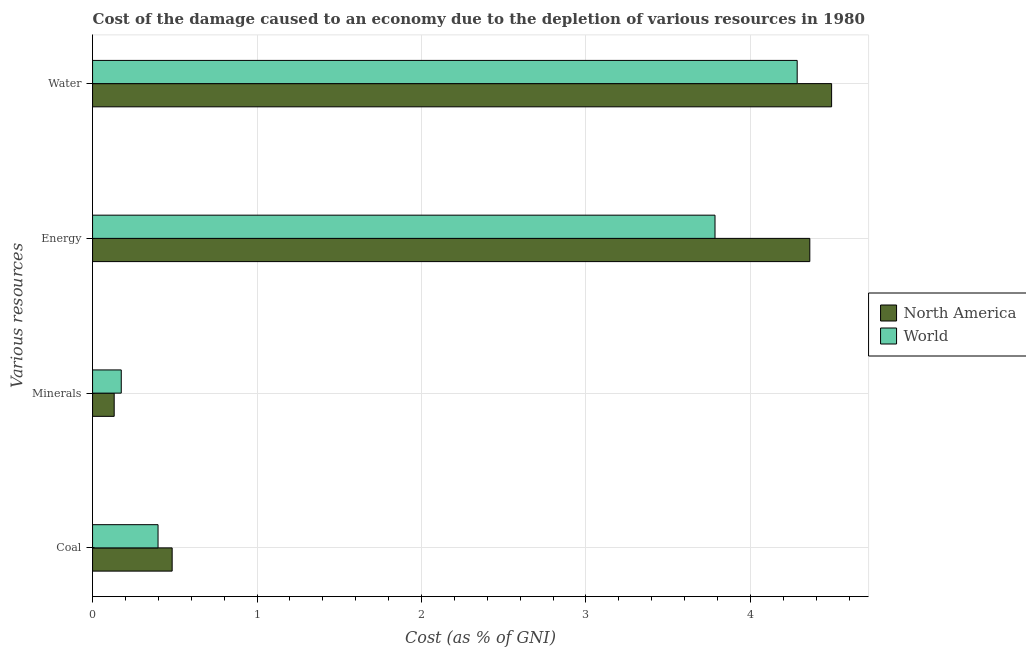How many different coloured bars are there?
Keep it short and to the point. 2. How many bars are there on the 4th tick from the top?
Keep it short and to the point. 2. How many bars are there on the 4th tick from the bottom?
Give a very brief answer. 2. What is the label of the 3rd group of bars from the top?
Provide a short and direct response. Minerals. What is the cost of damage due to depletion of minerals in North America?
Give a very brief answer. 0.13. Across all countries, what is the maximum cost of damage due to depletion of minerals?
Give a very brief answer. 0.17. Across all countries, what is the minimum cost of damage due to depletion of energy?
Provide a short and direct response. 3.78. In which country was the cost of damage due to depletion of energy maximum?
Give a very brief answer. North America. In which country was the cost of damage due to depletion of coal minimum?
Your answer should be very brief. World. What is the total cost of damage due to depletion of minerals in the graph?
Offer a terse response. 0.31. What is the difference between the cost of damage due to depletion of water in World and that in North America?
Ensure brevity in your answer.  -0.21. What is the difference between the cost of damage due to depletion of minerals in North America and the cost of damage due to depletion of energy in World?
Provide a short and direct response. -3.65. What is the average cost of damage due to depletion of coal per country?
Ensure brevity in your answer.  0.44. What is the difference between the cost of damage due to depletion of energy and cost of damage due to depletion of water in North America?
Your answer should be very brief. -0.13. What is the ratio of the cost of damage due to depletion of coal in North America to that in World?
Keep it short and to the point. 1.22. What is the difference between the highest and the second highest cost of damage due to depletion of minerals?
Give a very brief answer. 0.04. What is the difference between the highest and the lowest cost of damage due to depletion of coal?
Keep it short and to the point. 0.09. What does the 1st bar from the top in Minerals represents?
Give a very brief answer. World. What does the 1st bar from the bottom in Water represents?
Offer a very short reply. North America. Is it the case that in every country, the sum of the cost of damage due to depletion of coal and cost of damage due to depletion of minerals is greater than the cost of damage due to depletion of energy?
Your answer should be compact. No. Are all the bars in the graph horizontal?
Offer a terse response. Yes. How many countries are there in the graph?
Offer a terse response. 2. Does the graph contain any zero values?
Keep it short and to the point. No. What is the title of the graph?
Make the answer very short. Cost of the damage caused to an economy due to the depletion of various resources in 1980 . What is the label or title of the X-axis?
Your answer should be very brief. Cost (as % of GNI). What is the label or title of the Y-axis?
Your response must be concise. Various resources. What is the Cost (as % of GNI) in North America in Coal?
Your answer should be compact. 0.48. What is the Cost (as % of GNI) in World in Coal?
Ensure brevity in your answer.  0.4. What is the Cost (as % of GNI) in North America in Minerals?
Offer a very short reply. 0.13. What is the Cost (as % of GNI) of World in Minerals?
Your answer should be very brief. 0.17. What is the Cost (as % of GNI) of North America in Energy?
Provide a short and direct response. 4.36. What is the Cost (as % of GNI) of World in Energy?
Provide a short and direct response. 3.78. What is the Cost (as % of GNI) of North America in Water?
Provide a succinct answer. 4.49. What is the Cost (as % of GNI) of World in Water?
Provide a succinct answer. 4.28. Across all Various resources, what is the maximum Cost (as % of GNI) in North America?
Give a very brief answer. 4.49. Across all Various resources, what is the maximum Cost (as % of GNI) in World?
Your answer should be very brief. 4.28. Across all Various resources, what is the minimum Cost (as % of GNI) in North America?
Ensure brevity in your answer.  0.13. Across all Various resources, what is the minimum Cost (as % of GNI) of World?
Give a very brief answer. 0.17. What is the total Cost (as % of GNI) in North America in the graph?
Provide a succinct answer. 9.47. What is the total Cost (as % of GNI) of World in the graph?
Your answer should be compact. 8.64. What is the difference between the Cost (as % of GNI) of North America in Coal and that in Minerals?
Make the answer very short. 0.35. What is the difference between the Cost (as % of GNI) of World in Coal and that in Minerals?
Your response must be concise. 0.22. What is the difference between the Cost (as % of GNI) of North America in Coal and that in Energy?
Your answer should be very brief. -3.88. What is the difference between the Cost (as % of GNI) in World in Coal and that in Energy?
Give a very brief answer. -3.39. What is the difference between the Cost (as % of GNI) in North America in Coal and that in Water?
Provide a short and direct response. -4.01. What is the difference between the Cost (as % of GNI) of World in Coal and that in Water?
Offer a terse response. -3.89. What is the difference between the Cost (as % of GNI) in North America in Minerals and that in Energy?
Provide a succinct answer. -4.23. What is the difference between the Cost (as % of GNI) of World in Minerals and that in Energy?
Your response must be concise. -3.61. What is the difference between the Cost (as % of GNI) in North America in Minerals and that in Water?
Provide a short and direct response. -4.36. What is the difference between the Cost (as % of GNI) of World in Minerals and that in Water?
Keep it short and to the point. -4.11. What is the difference between the Cost (as % of GNI) of North America in Energy and that in Water?
Provide a succinct answer. -0.13. What is the difference between the Cost (as % of GNI) of World in Energy and that in Water?
Keep it short and to the point. -0.5. What is the difference between the Cost (as % of GNI) of North America in Coal and the Cost (as % of GNI) of World in Minerals?
Your answer should be compact. 0.31. What is the difference between the Cost (as % of GNI) of North America in Coal and the Cost (as % of GNI) of World in Energy?
Ensure brevity in your answer.  -3.3. What is the difference between the Cost (as % of GNI) in North America in Coal and the Cost (as % of GNI) in World in Water?
Your answer should be very brief. -3.8. What is the difference between the Cost (as % of GNI) of North America in Minerals and the Cost (as % of GNI) of World in Energy?
Your answer should be compact. -3.65. What is the difference between the Cost (as % of GNI) of North America in Minerals and the Cost (as % of GNI) of World in Water?
Offer a terse response. -4.15. What is the difference between the Cost (as % of GNI) of North America in Energy and the Cost (as % of GNI) of World in Water?
Your response must be concise. 0.08. What is the average Cost (as % of GNI) in North America per Various resources?
Give a very brief answer. 2.37. What is the average Cost (as % of GNI) of World per Various resources?
Your response must be concise. 2.16. What is the difference between the Cost (as % of GNI) of North America and Cost (as % of GNI) of World in Coal?
Keep it short and to the point. 0.09. What is the difference between the Cost (as % of GNI) in North America and Cost (as % of GNI) in World in Minerals?
Offer a very short reply. -0.04. What is the difference between the Cost (as % of GNI) of North America and Cost (as % of GNI) of World in Energy?
Provide a short and direct response. 0.58. What is the difference between the Cost (as % of GNI) of North America and Cost (as % of GNI) of World in Water?
Your answer should be compact. 0.21. What is the ratio of the Cost (as % of GNI) of North America in Coal to that in Minerals?
Ensure brevity in your answer.  3.68. What is the ratio of the Cost (as % of GNI) in World in Coal to that in Minerals?
Your answer should be compact. 2.28. What is the ratio of the Cost (as % of GNI) in North America in Coal to that in Energy?
Provide a succinct answer. 0.11. What is the ratio of the Cost (as % of GNI) of World in Coal to that in Energy?
Provide a short and direct response. 0.11. What is the ratio of the Cost (as % of GNI) in North America in Coal to that in Water?
Your answer should be very brief. 0.11. What is the ratio of the Cost (as % of GNI) in World in Coal to that in Water?
Ensure brevity in your answer.  0.09. What is the ratio of the Cost (as % of GNI) of North America in Minerals to that in Energy?
Provide a succinct answer. 0.03. What is the ratio of the Cost (as % of GNI) in World in Minerals to that in Energy?
Your answer should be compact. 0.05. What is the ratio of the Cost (as % of GNI) in North America in Minerals to that in Water?
Your answer should be compact. 0.03. What is the ratio of the Cost (as % of GNI) of World in Minerals to that in Water?
Provide a succinct answer. 0.04. What is the ratio of the Cost (as % of GNI) of North America in Energy to that in Water?
Your response must be concise. 0.97. What is the ratio of the Cost (as % of GNI) of World in Energy to that in Water?
Offer a very short reply. 0.88. What is the difference between the highest and the second highest Cost (as % of GNI) in North America?
Make the answer very short. 0.13. What is the difference between the highest and the second highest Cost (as % of GNI) in World?
Offer a terse response. 0.5. What is the difference between the highest and the lowest Cost (as % of GNI) in North America?
Provide a short and direct response. 4.36. What is the difference between the highest and the lowest Cost (as % of GNI) in World?
Give a very brief answer. 4.11. 